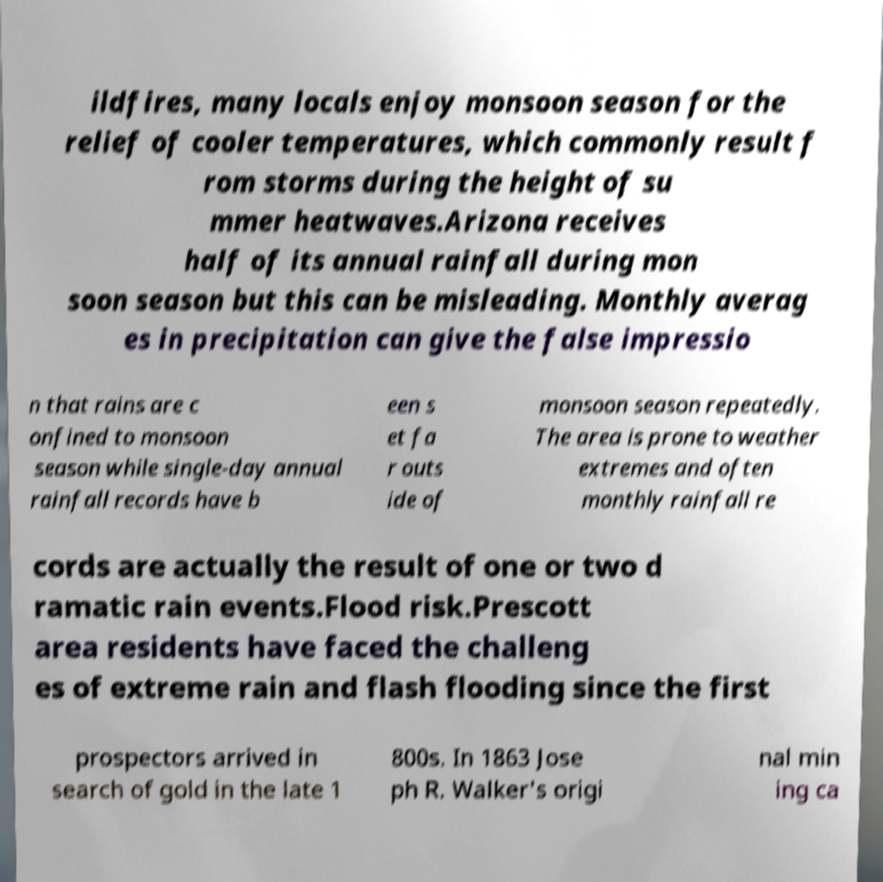Please read and relay the text visible in this image. What does it say? ildfires, many locals enjoy monsoon season for the relief of cooler temperatures, which commonly result f rom storms during the height of su mmer heatwaves.Arizona receives half of its annual rainfall during mon soon season but this can be misleading. Monthly averag es in precipitation can give the false impressio n that rains are c onfined to monsoon season while single-day annual rainfall records have b een s et fa r outs ide of monsoon season repeatedly. The area is prone to weather extremes and often monthly rainfall re cords are actually the result of one or two d ramatic rain events.Flood risk.Prescott area residents have faced the challeng es of extreme rain and flash flooding since the first prospectors arrived in search of gold in the late 1 800s. In 1863 Jose ph R. Walker's origi nal min ing ca 